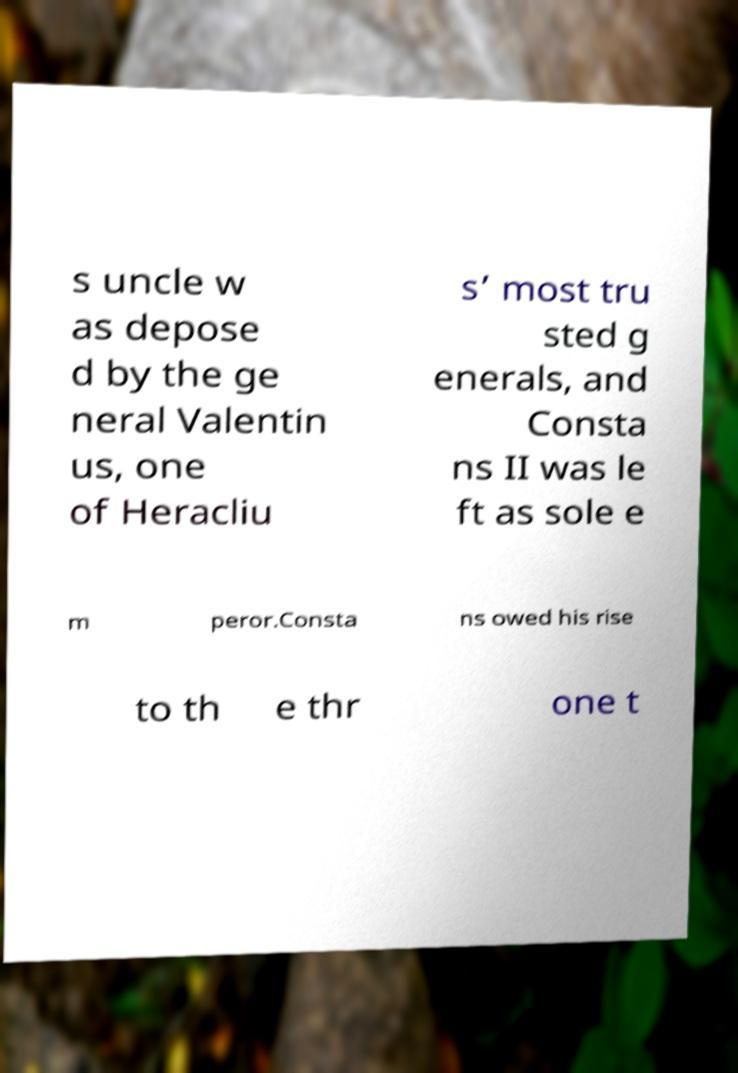Could you extract and type out the text from this image? s uncle w as depose d by the ge neral Valentin us, one of Heracliu s’ most tru sted g enerals, and Consta ns II was le ft as sole e m peror.Consta ns owed his rise to th e thr one t 